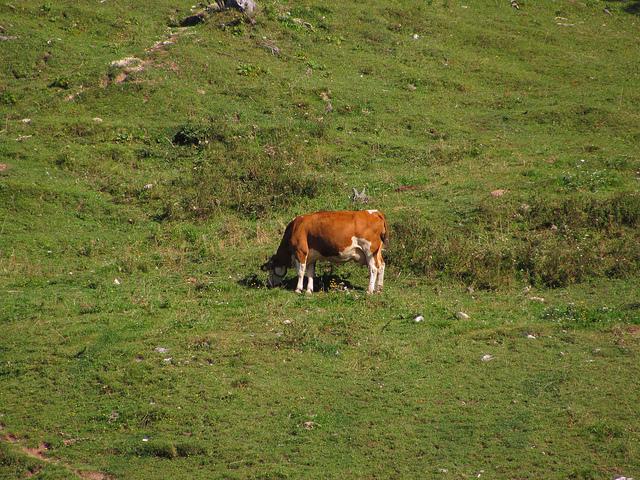What is the name of this animal?
Answer briefly. Cow. Does the cow have spots?
Answer briefly. Yes. Is this a big brown dog?
Quick response, please. No. Is this a grassy field?
Keep it brief. Yes. 